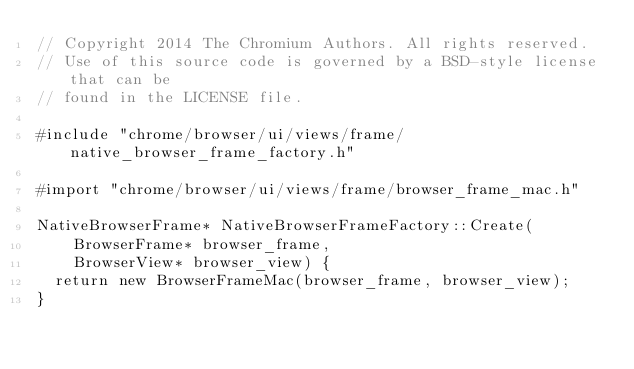<code> <loc_0><loc_0><loc_500><loc_500><_ObjectiveC_>// Copyright 2014 The Chromium Authors. All rights reserved.
// Use of this source code is governed by a BSD-style license that can be
// found in the LICENSE file.

#include "chrome/browser/ui/views/frame/native_browser_frame_factory.h"

#import "chrome/browser/ui/views/frame/browser_frame_mac.h"

NativeBrowserFrame* NativeBrowserFrameFactory::Create(
    BrowserFrame* browser_frame,
    BrowserView* browser_view) {
  return new BrowserFrameMac(browser_frame, browser_view);
}
</code> 